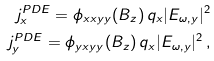<formula> <loc_0><loc_0><loc_500><loc_500>j ^ { P D E } _ { x } = \phi _ { x x y y } ( B _ { z } ) \, q _ { x } | E _ { \omega , y } | ^ { 2 } \\ j ^ { P D E } _ { y } = \phi _ { y x y y } ( B _ { z } ) \, q _ { x } | E _ { \omega , y } | ^ { 2 } \, ,</formula> 